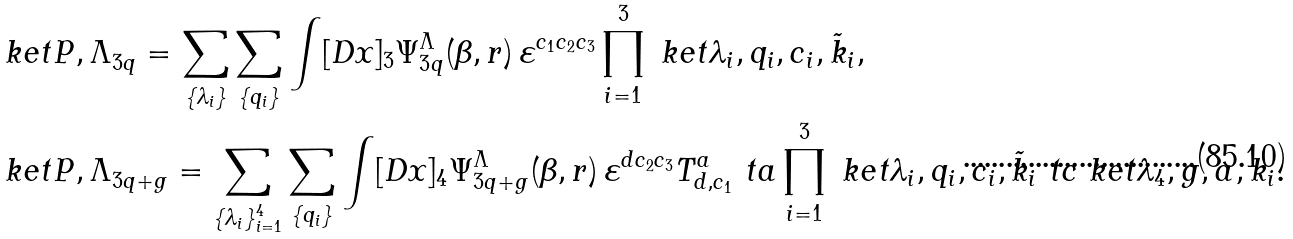<formula> <loc_0><loc_0><loc_500><loc_500>& \ k e t { P , \Lambda } _ { 3 q } = \sum _ { \{ \lambda _ { i } \} } \sum _ { \{ q _ { i } \} } \int [ D x ] _ { 3 } \Psi ^ { \Lambda } _ { 3 q } ( \beta , r ) \, \varepsilon ^ { c _ { 1 } c _ { 2 } c _ { 3 } } \prod _ { i = 1 } ^ { 3 } \ k e t { \lambda _ { i } , q _ { i } , c _ { i } , \tilde { k } _ { i } } , \\ & \ k e t { P , \Lambda } _ { 3 q + g } = \sum _ { \{ \lambda _ { i } \} _ { i = 1 } ^ { 4 } } \sum _ { \{ q _ { i } \} } \int [ D x ] _ { 4 } \Psi ^ { \Lambda } _ { 3 q + g } ( \beta , r ) \, \varepsilon ^ { d c _ { 2 } c _ { 3 } } T ^ { a } _ { d , c _ { 1 } } \ t a \prod _ { i = 1 } ^ { 3 } \ k e t { \lambda _ { i } , q _ { i } , c _ { i } , \tilde { k } _ { i } } \ t c \ k e t { \lambda _ { 4 } , g , a , k _ { i } } .</formula> 